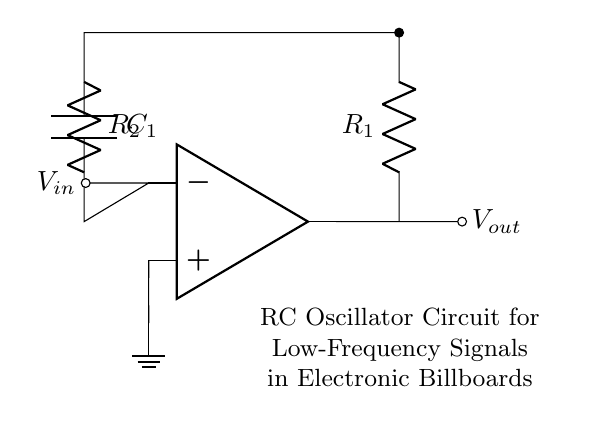What are the main components in the circuit? The circuit contains two resistors, R1 and R2, and one capacitor, C1, along with an operational amplifier. These are the key elements that define the behavior of the oscillator.
Answer: R1, R2, C1, operational amplifier What is the function of the operational amplifier? The operational amplifier in this circuit acts as a voltage amplifier, providing the necessary feedback for oscillation. It amplifies the input signal to create a sustained output signal that can drive low-frequency oscillations.
Answer: Voltage amplifier Which components are responsible for determining the frequency of the output signal? The frequency of the output signal in an RC oscillator is primarily determined by the values of the resistors R1 and R2 and the capacitor C1, based on the formula involving these components.
Answer: R1, R2, C1 How many feedback paths are present in the circuit? The circuit has one feedback path that connects the output of the operational amplifier back to its inverting input through the resistors and capacitor, which is crucial for maintaining oscillation.
Answer: One If R1 equals R2, how does this affect the output frequency? When R1 equals R2, the frequency of the output signal becomes a function of equal resistor values and the value of C1, which simplifies the frequency calculation and typically results in a specific predictable frequency.
Answer: Predictable frequency What is the primary application of this RC oscillator circuit? This RC oscillator circuit is primarily used for generating low-frequency signals, which can be applied in electronic billboards and digital signage to control display functionalities.
Answer: Electronic billboards, digital signage 